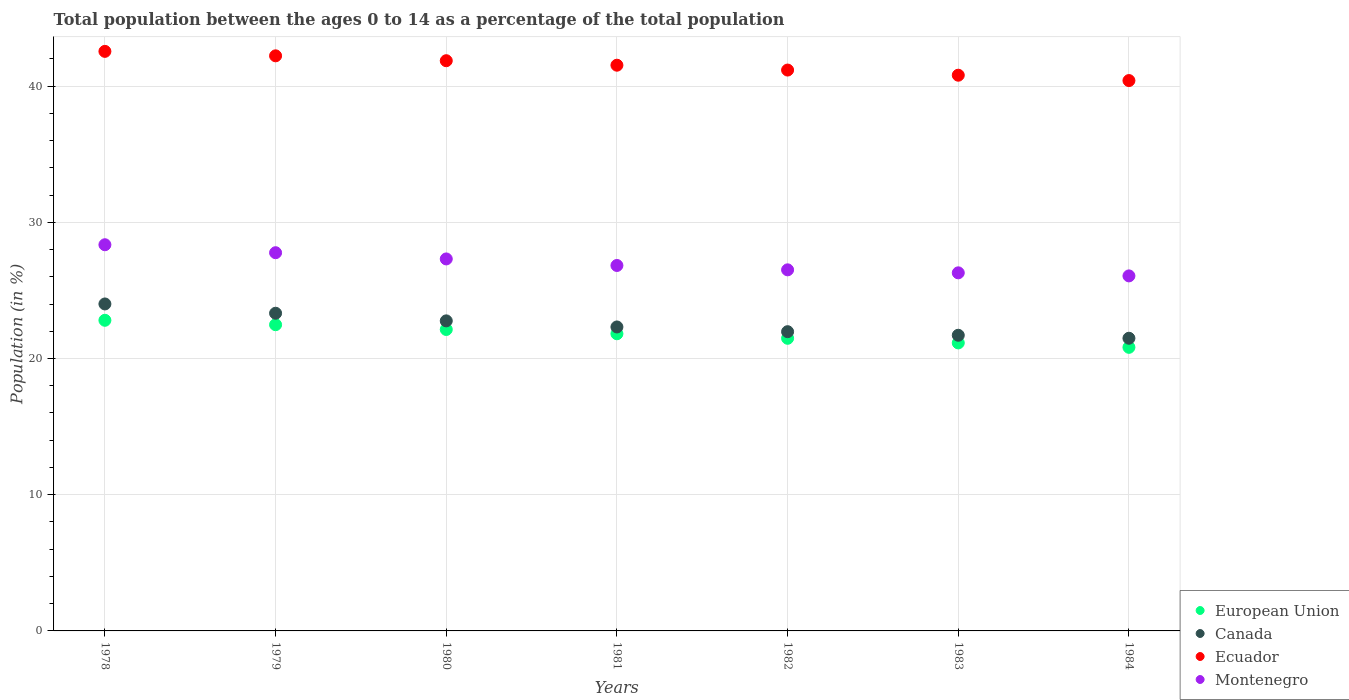Is the number of dotlines equal to the number of legend labels?
Offer a terse response. Yes. What is the percentage of the population ages 0 to 14 in Canada in 1981?
Give a very brief answer. 22.32. Across all years, what is the maximum percentage of the population ages 0 to 14 in Ecuador?
Give a very brief answer. 42.55. Across all years, what is the minimum percentage of the population ages 0 to 14 in Montenegro?
Your answer should be compact. 26.07. In which year was the percentage of the population ages 0 to 14 in Canada maximum?
Your answer should be very brief. 1978. What is the total percentage of the population ages 0 to 14 in European Union in the graph?
Ensure brevity in your answer.  152.69. What is the difference between the percentage of the population ages 0 to 14 in Ecuador in 1979 and that in 1982?
Your response must be concise. 1.04. What is the difference between the percentage of the population ages 0 to 14 in Canada in 1984 and the percentage of the population ages 0 to 14 in Montenegro in 1982?
Provide a short and direct response. -5.02. What is the average percentage of the population ages 0 to 14 in Montenegro per year?
Give a very brief answer. 27.02. In the year 1980, what is the difference between the percentage of the population ages 0 to 14 in Ecuador and percentage of the population ages 0 to 14 in European Union?
Make the answer very short. 19.73. In how many years, is the percentage of the population ages 0 to 14 in Ecuador greater than 28?
Offer a terse response. 7. What is the ratio of the percentage of the population ages 0 to 14 in Montenegro in 1979 to that in 1981?
Offer a terse response. 1.03. Is the percentage of the population ages 0 to 14 in European Union in 1980 less than that in 1982?
Offer a very short reply. No. Is the difference between the percentage of the population ages 0 to 14 in Ecuador in 1979 and 1982 greater than the difference between the percentage of the population ages 0 to 14 in European Union in 1979 and 1982?
Offer a very short reply. Yes. What is the difference between the highest and the second highest percentage of the population ages 0 to 14 in Canada?
Your response must be concise. 0.68. What is the difference between the highest and the lowest percentage of the population ages 0 to 14 in Ecuador?
Give a very brief answer. 2.14. Is the sum of the percentage of the population ages 0 to 14 in Montenegro in 1978 and 1980 greater than the maximum percentage of the population ages 0 to 14 in Canada across all years?
Offer a very short reply. Yes. Is it the case that in every year, the sum of the percentage of the population ages 0 to 14 in European Union and percentage of the population ages 0 to 14 in Montenegro  is greater than the percentage of the population ages 0 to 14 in Ecuador?
Provide a short and direct response. Yes. Does the percentage of the population ages 0 to 14 in Ecuador monotonically increase over the years?
Keep it short and to the point. No. How many dotlines are there?
Keep it short and to the point. 4. What is the difference between two consecutive major ticks on the Y-axis?
Give a very brief answer. 10. Are the values on the major ticks of Y-axis written in scientific E-notation?
Make the answer very short. No. Where does the legend appear in the graph?
Your response must be concise. Bottom right. How many legend labels are there?
Your answer should be compact. 4. What is the title of the graph?
Your response must be concise. Total population between the ages 0 to 14 as a percentage of the total population. Does "Morocco" appear as one of the legend labels in the graph?
Make the answer very short. No. What is the label or title of the X-axis?
Ensure brevity in your answer.  Years. What is the label or title of the Y-axis?
Give a very brief answer. Population (in %). What is the Population (in %) of European Union in 1978?
Offer a terse response. 22.81. What is the Population (in %) of Canada in 1978?
Give a very brief answer. 24.01. What is the Population (in %) in Ecuador in 1978?
Offer a very short reply. 42.55. What is the Population (in %) in Montenegro in 1978?
Keep it short and to the point. 28.35. What is the Population (in %) in European Union in 1979?
Keep it short and to the point. 22.48. What is the Population (in %) in Canada in 1979?
Give a very brief answer. 23.32. What is the Population (in %) of Ecuador in 1979?
Offer a terse response. 42.22. What is the Population (in %) of Montenegro in 1979?
Offer a terse response. 27.77. What is the Population (in %) in European Union in 1980?
Your response must be concise. 22.13. What is the Population (in %) of Canada in 1980?
Make the answer very short. 22.76. What is the Population (in %) of Ecuador in 1980?
Your response must be concise. 41.86. What is the Population (in %) in Montenegro in 1980?
Give a very brief answer. 27.31. What is the Population (in %) in European Union in 1981?
Keep it short and to the point. 21.82. What is the Population (in %) in Canada in 1981?
Your answer should be compact. 22.32. What is the Population (in %) in Ecuador in 1981?
Keep it short and to the point. 41.53. What is the Population (in %) of Montenegro in 1981?
Make the answer very short. 26.83. What is the Population (in %) of European Union in 1982?
Provide a succinct answer. 21.48. What is the Population (in %) of Canada in 1982?
Make the answer very short. 21.97. What is the Population (in %) of Ecuador in 1982?
Offer a terse response. 41.18. What is the Population (in %) of Montenegro in 1982?
Your response must be concise. 26.51. What is the Population (in %) of European Union in 1983?
Provide a succinct answer. 21.15. What is the Population (in %) of Canada in 1983?
Keep it short and to the point. 21.71. What is the Population (in %) in Ecuador in 1983?
Your answer should be very brief. 40.8. What is the Population (in %) in Montenegro in 1983?
Your response must be concise. 26.29. What is the Population (in %) in European Union in 1984?
Your answer should be compact. 20.82. What is the Population (in %) in Canada in 1984?
Make the answer very short. 21.49. What is the Population (in %) in Ecuador in 1984?
Keep it short and to the point. 40.41. What is the Population (in %) in Montenegro in 1984?
Your answer should be very brief. 26.07. Across all years, what is the maximum Population (in %) of European Union?
Make the answer very short. 22.81. Across all years, what is the maximum Population (in %) of Canada?
Give a very brief answer. 24.01. Across all years, what is the maximum Population (in %) of Ecuador?
Keep it short and to the point. 42.55. Across all years, what is the maximum Population (in %) of Montenegro?
Offer a very short reply. 28.35. Across all years, what is the minimum Population (in %) of European Union?
Your answer should be compact. 20.82. Across all years, what is the minimum Population (in %) in Canada?
Make the answer very short. 21.49. Across all years, what is the minimum Population (in %) in Ecuador?
Keep it short and to the point. 40.41. Across all years, what is the minimum Population (in %) of Montenegro?
Give a very brief answer. 26.07. What is the total Population (in %) in European Union in the graph?
Give a very brief answer. 152.69. What is the total Population (in %) in Canada in the graph?
Keep it short and to the point. 157.57. What is the total Population (in %) in Ecuador in the graph?
Offer a terse response. 290.56. What is the total Population (in %) in Montenegro in the graph?
Make the answer very short. 189.13. What is the difference between the Population (in %) of European Union in 1978 and that in 1979?
Make the answer very short. 0.33. What is the difference between the Population (in %) of Canada in 1978 and that in 1979?
Keep it short and to the point. 0.68. What is the difference between the Population (in %) of Ecuador in 1978 and that in 1979?
Give a very brief answer. 0.33. What is the difference between the Population (in %) in Montenegro in 1978 and that in 1979?
Provide a succinct answer. 0.59. What is the difference between the Population (in %) in European Union in 1978 and that in 1980?
Offer a terse response. 0.68. What is the difference between the Population (in %) in Canada in 1978 and that in 1980?
Give a very brief answer. 1.24. What is the difference between the Population (in %) of Ecuador in 1978 and that in 1980?
Your response must be concise. 0.69. What is the difference between the Population (in %) of Montenegro in 1978 and that in 1980?
Keep it short and to the point. 1.04. What is the difference between the Population (in %) of European Union in 1978 and that in 1981?
Your answer should be very brief. 0.99. What is the difference between the Population (in %) of Canada in 1978 and that in 1981?
Keep it short and to the point. 1.69. What is the difference between the Population (in %) in Ecuador in 1978 and that in 1981?
Keep it short and to the point. 1.02. What is the difference between the Population (in %) in Montenegro in 1978 and that in 1981?
Your answer should be compact. 1.52. What is the difference between the Population (in %) in European Union in 1978 and that in 1982?
Keep it short and to the point. 1.32. What is the difference between the Population (in %) in Canada in 1978 and that in 1982?
Keep it short and to the point. 2.04. What is the difference between the Population (in %) in Ecuador in 1978 and that in 1982?
Provide a short and direct response. 1.37. What is the difference between the Population (in %) of Montenegro in 1978 and that in 1982?
Your response must be concise. 1.84. What is the difference between the Population (in %) in European Union in 1978 and that in 1983?
Your response must be concise. 1.66. What is the difference between the Population (in %) of Canada in 1978 and that in 1983?
Give a very brief answer. 2.3. What is the difference between the Population (in %) of Ecuador in 1978 and that in 1983?
Give a very brief answer. 1.75. What is the difference between the Population (in %) in Montenegro in 1978 and that in 1983?
Your answer should be very brief. 2.06. What is the difference between the Population (in %) of European Union in 1978 and that in 1984?
Your answer should be compact. 1.99. What is the difference between the Population (in %) of Canada in 1978 and that in 1984?
Make the answer very short. 2.52. What is the difference between the Population (in %) in Ecuador in 1978 and that in 1984?
Your answer should be very brief. 2.14. What is the difference between the Population (in %) of Montenegro in 1978 and that in 1984?
Offer a very short reply. 2.29. What is the difference between the Population (in %) in European Union in 1979 and that in 1980?
Make the answer very short. 0.35. What is the difference between the Population (in %) of Canada in 1979 and that in 1980?
Your answer should be very brief. 0.56. What is the difference between the Population (in %) in Ecuador in 1979 and that in 1980?
Your answer should be very brief. 0.36. What is the difference between the Population (in %) in Montenegro in 1979 and that in 1980?
Your answer should be compact. 0.46. What is the difference between the Population (in %) in European Union in 1979 and that in 1981?
Offer a very short reply. 0.66. What is the difference between the Population (in %) in Ecuador in 1979 and that in 1981?
Provide a short and direct response. 0.69. What is the difference between the Population (in %) of Montenegro in 1979 and that in 1981?
Your answer should be compact. 0.94. What is the difference between the Population (in %) of Canada in 1979 and that in 1982?
Give a very brief answer. 1.35. What is the difference between the Population (in %) of Ecuador in 1979 and that in 1982?
Your answer should be compact. 1.04. What is the difference between the Population (in %) of Montenegro in 1979 and that in 1982?
Give a very brief answer. 1.26. What is the difference between the Population (in %) in European Union in 1979 and that in 1983?
Offer a very short reply. 1.34. What is the difference between the Population (in %) in Canada in 1979 and that in 1983?
Offer a terse response. 1.62. What is the difference between the Population (in %) of Ecuador in 1979 and that in 1983?
Make the answer very short. 1.42. What is the difference between the Population (in %) of Montenegro in 1979 and that in 1983?
Make the answer very short. 1.48. What is the difference between the Population (in %) of European Union in 1979 and that in 1984?
Provide a succinct answer. 1.66. What is the difference between the Population (in %) of Canada in 1979 and that in 1984?
Ensure brevity in your answer.  1.84. What is the difference between the Population (in %) in Ecuador in 1979 and that in 1984?
Offer a terse response. 1.82. What is the difference between the Population (in %) of Montenegro in 1979 and that in 1984?
Give a very brief answer. 1.7. What is the difference between the Population (in %) of European Union in 1980 and that in 1981?
Your answer should be compact. 0.31. What is the difference between the Population (in %) of Canada in 1980 and that in 1981?
Provide a short and direct response. 0.45. What is the difference between the Population (in %) in Ecuador in 1980 and that in 1981?
Offer a very short reply. 0.33. What is the difference between the Population (in %) in Montenegro in 1980 and that in 1981?
Provide a short and direct response. 0.48. What is the difference between the Population (in %) in European Union in 1980 and that in 1982?
Ensure brevity in your answer.  0.65. What is the difference between the Population (in %) of Canada in 1980 and that in 1982?
Offer a terse response. 0.79. What is the difference between the Population (in %) in Ecuador in 1980 and that in 1982?
Your answer should be compact. 0.69. What is the difference between the Population (in %) of Montenegro in 1980 and that in 1982?
Ensure brevity in your answer.  0.8. What is the difference between the Population (in %) in European Union in 1980 and that in 1983?
Offer a very short reply. 0.99. What is the difference between the Population (in %) of Canada in 1980 and that in 1983?
Your answer should be compact. 1.06. What is the difference between the Population (in %) in Ecuador in 1980 and that in 1983?
Offer a very short reply. 1.06. What is the difference between the Population (in %) of Montenegro in 1980 and that in 1983?
Provide a short and direct response. 1.02. What is the difference between the Population (in %) of European Union in 1980 and that in 1984?
Provide a short and direct response. 1.31. What is the difference between the Population (in %) in Canada in 1980 and that in 1984?
Keep it short and to the point. 1.28. What is the difference between the Population (in %) in Ecuador in 1980 and that in 1984?
Keep it short and to the point. 1.46. What is the difference between the Population (in %) of Montenegro in 1980 and that in 1984?
Your response must be concise. 1.25. What is the difference between the Population (in %) in European Union in 1981 and that in 1982?
Keep it short and to the point. 0.33. What is the difference between the Population (in %) in Canada in 1981 and that in 1982?
Make the answer very short. 0.35. What is the difference between the Population (in %) in Ecuador in 1981 and that in 1982?
Offer a very short reply. 0.36. What is the difference between the Population (in %) of Montenegro in 1981 and that in 1982?
Provide a succinct answer. 0.32. What is the difference between the Population (in %) in European Union in 1981 and that in 1983?
Give a very brief answer. 0.67. What is the difference between the Population (in %) in Canada in 1981 and that in 1983?
Your response must be concise. 0.61. What is the difference between the Population (in %) in Ecuador in 1981 and that in 1983?
Give a very brief answer. 0.73. What is the difference between the Population (in %) of Montenegro in 1981 and that in 1983?
Offer a very short reply. 0.54. What is the difference between the Population (in %) in Canada in 1981 and that in 1984?
Offer a very short reply. 0.83. What is the difference between the Population (in %) of Ecuador in 1981 and that in 1984?
Offer a very short reply. 1.13. What is the difference between the Population (in %) in Montenegro in 1981 and that in 1984?
Make the answer very short. 0.76. What is the difference between the Population (in %) of European Union in 1982 and that in 1983?
Offer a terse response. 0.34. What is the difference between the Population (in %) in Canada in 1982 and that in 1983?
Provide a short and direct response. 0.26. What is the difference between the Population (in %) of Ecuador in 1982 and that in 1983?
Give a very brief answer. 0.38. What is the difference between the Population (in %) of Montenegro in 1982 and that in 1983?
Provide a short and direct response. 0.22. What is the difference between the Population (in %) in European Union in 1982 and that in 1984?
Ensure brevity in your answer.  0.66. What is the difference between the Population (in %) of Canada in 1982 and that in 1984?
Provide a short and direct response. 0.48. What is the difference between the Population (in %) of Ecuador in 1982 and that in 1984?
Provide a succinct answer. 0.77. What is the difference between the Population (in %) in Montenegro in 1982 and that in 1984?
Provide a succinct answer. 0.44. What is the difference between the Population (in %) of European Union in 1983 and that in 1984?
Ensure brevity in your answer.  0.32. What is the difference between the Population (in %) of Canada in 1983 and that in 1984?
Give a very brief answer. 0.22. What is the difference between the Population (in %) in Ecuador in 1983 and that in 1984?
Keep it short and to the point. 0.39. What is the difference between the Population (in %) in Montenegro in 1983 and that in 1984?
Your answer should be very brief. 0.22. What is the difference between the Population (in %) in European Union in 1978 and the Population (in %) in Canada in 1979?
Make the answer very short. -0.52. What is the difference between the Population (in %) of European Union in 1978 and the Population (in %) of Ecuador in 1979?
Ensure brevity in your answer.  -19.42. What is the difference between the Population (in %) of European Union in 1978 and the Population (in %) of Montenegro in 1979?
Give a very brief answer. -4.96. What is the difference between the Population (in %) in Canada in 1978 and the Population (in %) in Ecuador in 1979?
Keep it short and to the point. -18.22. What is the difference between the Population (in %) in Canada in 1978 and the Population (in %) in Montenegro in 1979?
Give a very brief answer. -3.76. What is the difference between the Population (in %) of Ecuador in 1978 and the Population (in %) of Montenegro in 1979?
Keep it short and to the point. 14.78. What is the difference between the Population (in %) in European Union in 1978 and the Population (in %) in Canada in 1980?
Offer a very short reply. 0.04. What is the difference between the Population (in %) in European Union in 1978 and the Population (in %) in Ecuador in 1980?
Make the answer very short. -19.06. What is the difference between the Population (in %) of European Union in 1978 and the Population (in %) of Montenegro in 1980?
Ensure brevity in your answer.  -4.5. What is the difference between the Population (in %) in Canada in 1978 and the Population (in %) in Ecuador in 1980?
Your answer should be very brief. -17.86. What is the difference between the Population (in %) in Canada in 1978 and the Population (in %) in Montenegro in 1980?
Provide a short and direct response. -3.31. What is the difference between the Population (in %) of Ecuador in 1978 and the Population (in %) of Montenegro in 1980?
Offer a very short reply. 15.24. What is the difference between the Population (in %) in European Union in 1978 and the Population (in %) in Canada in 1981?
Keep it short and to the point. 0.49. What is the difference between the Population (in %) in European Union in 1978 and the Population (in %) in Ecuador in 1981?
Give a very brief answer. -18.73. What is the difference between the Population (in %) of European Union in 1978 and the Population (in %) of Montenegro in 1981?
Your answer should be compact. -4.02. What is the difference between the Population (in %) in Canada in 1978 and the Population (in %) in Ecuador in 1981?
Provide a succinct answer. -17.53. What is the difference between the Population (in %) in Canada in 1978 and the Population (in %) in Montenegro in 1981?
Your answer should be compact. -2.82. What is the difference between the Population (in %) of Ecuador in 1978 and the Population (in %) of Montenegro in 1981?
Offer a terse response. 15.72. What is the difference between the Population (in %) of European Union in 1978 and the Population (in %) of Canada in 1982?
Offer a very short reply. 0.84. What is the difference between the Population (in %) of European Union in 1978 and the Population (in %) of Ecuador in 1982?
Your response must be concise. -18.37. What is the difference between the Population (in %) of European Union in 1978 and the Population (in %) of Montenegro in 1982?
Offer a very short reply. -3.7. What is the difference between the Population (in %) in Canada in 1978 and the Population (in %) in Ecuador in 1982?
Your answer should be compact. -17.17. What is the difference between the Population (in %) in Canada in 1978 and the Population (in %) in Montenegro in 1982?
Provide a short and direct response. -2.5. What is the difference between the Population (in %) in Ecuador in 1978 and the Population (in %) in Montenegro in 1982?
Your answer should be compact. 16.04. What is the difference between the Population (in %) of European Union in 1978 and the Population (in %) of Canada in 1983?
Your response must be concise. 1.1. What is the difference between the Population (in %) of European Union in 1978 and the Population (in %) of Ecuador in 1983?
Offer a very short reply. -17.99. What is the difference between the Population (in %) in European Union in 1978 and the Population (in %) in Montenegro in 1983?
Ensure brevity in your answer.  -3.48. What is the difference between the Population (in %) of Canada in 1978 and the Population (in %) of Ecuador in 1983?
Ensure brevity in your answer.  -16.79. What is the difference between the Population (in %) of Canada in 1978 and the Population (in %) of Montenegro in 1983?
Your response must be concise. -2.29. What is the difference between the Population (in %) of Ecuador in 1978 and the Population (in %) of Montenegro in 1983?
Your answer should be very brief. 16.26. What is the difference between the Population (in %) of European Union in 1978 and the Population (in %) of Canada in 1984?
Make the answer very short. 1.32. What is the difference between the Population (in %) in European Union in 1978 and the Population (in %) in Ecuador in 1984?
Keep it short and to the point. -17.6. What is the difference between the Population (in %) in European Union in 1978 and the Population (in %) in Montenegro in 1984?
Your answer should be very brief. -3.26. What is the difference between the Population (in %) of Canada in 1978 and the Population (in %) of Ecuador in 1984?
Keep it short and to the point. -16.4. What is the difference between the Population (in %) of Canada in 1978 and the Population (in %) of Montenegro in 1984?
Ensure brevity in your answer.  -2.06. What is the difference between the Population (in %) in Ecuador in 1978 and the Population (in %) in Montenegro in 1984?
Your answer should be compact. 16.48. What is the difference between the Population (in %) of European Union in 1979 and the Population (in %) of Canada in 1980?
Offer a very short reply. -0.28. What is the difference between the Population (in %) in European Union in 1979 and the Population (in %) in Ecuador in 1980?
Make the answer very short. -19.38. What is the difference between the Population (in %) in European Union in 1979 and the Population (in %) in Montenegro in 1980?
Provide a short and direct response. -4.83. What is the difference between the Population (in %) in Canada in 1979 and the Population (in %) in Ecuador in 1980?
Keep it short and to the point. -18.54. What is the difference between the Population (in %) of Canada in 1979 and the Population (in %) of Montenegro in 1980?
Ensure brevity in your answer.  -3.99. What is the difference between the Population (in %) of Ecuador in 1979 and the Population (in %) of Montenegro in 1980?
Offer a very short reply. 14.91. What is the difference between the Population (in %) in European Union in 1979 and the Population (in %) in Canada in 1981?
Offer a very short reply. 0.16. What is the difference between the Population (in %) in European Union in 1979 and the Population (in %) in Ecuador in 1981?
Provide a succinct answer. -19.05. What is the difference between the Population (in %) in European Union in 1979 and the Population (in %) in Montenegro in 1981?
Your response must be concise. -4.35. What is the difference between the Population (in %) in Canada in 1979 and the Population (in %) in Ecuador in 1981?
Your answer should be compact. -18.21. What is the difference between the Population (in %) of Canada in 1979 and the Population (in %) of Montenegro in 1981?
Provide a short and direct response. -3.51. What is the difference between the Population (in %) of Ecuador in 1979 and the Population (in %) of Montenegro in 1981?
Make the answer very short. 15.39. What is the difference between the Population (in %) in European Union in 1979 and the Population (in %) in Canada in 1982?
Your response must be concise. 0.51. What is the difference between the Population (in %) in European Union in 1979 and the Population (in %) in Ecuador in 1982?
Provide a succinct answer. -18.7. What is the difference between the Population (in %) in European Union in 1979 and the Population (in %) in Montenegro in 1982?
Make the answer very short. -4.03. What is the difference between the Population (in %) in Canada in 1979 and the Population (in %) in Ecuador in 1982?
Provide a succinct answer. -17.85. What is the difference between the Population (in %) of Canada in 1979 and the Population (in %) of Montenegro in 1982?
Your response must be concise. -3.19. What is the difference between the Population (in %) of Ecuador in 1979 and the Population (in %) of Montenegro in 1982?
Offer a very short reply. 15.71. What is the difference between the Population (in %) in European Union in 1979 and the Population (in %) in Canada in 1983?
Offer a very short reply. 0.77. What is the difference between the Population (in %) of European Union in 1979 and the Population (in %) of Ecuador in 1983?
Your response must be concise. -18.32. What is the difference between the Population (in %) of European Union in 1979 and the Population (in %) of Montenegro in 1983?
Your answer should be very brief. -3.81. What is the difference between the Population (in %) in Canada in 1979 and the Population (in %) in Ecuador in 1983?
Your answer should be compact. -17.48. What is the difference between the Population (in %) in Canada in 1979 and the Population (in %) in Montenegro in 1983?
Your answer should be compact. -2.97. What is the difference between the Population (in %) of Ecuador in 1979 and the Population (in %) of Montenegro in 1983?
Offer a terse response. 15.93. What is the difference between the Population (in %) of European Union in 1979 and the Population (in %) of Ecuador in 1984?
Your response must be concise. -17.93. What is the difference between the Population (in %) in European Union in 1979 and the Population (in %) in Montenegro in 1984?
Your response must be concise. -3.58. What is the difference between the Population (in %) in Canada in 1979 and the Population (in %) in Ecuador in 1984?
Your answer should be very brief. -17.08. What is the difference between the Population (in %) of Canada in 1979 and the Population (in %) of Montenegro in 1984?
Offer a very short reply. -2.74. What is the difference between the Population (in %) in Ecuador in 1979 and the Population (in %) in Montenegro in 1984?
Offer a terse response. 16.16. What is the difference between the Population (in %) of European Union in 1980 and the Population (in %) of Canada in 1981?
Your response must be concise. -0.19. What is the difference between the Population (in %) in European Union in 1980 and the Population (in %) in Ecuador in 1981?
Your response must be concise. -19.4. What is the difference between the Population (in %) of European Union in 1980 and the Population (in %) of Montenegro in 1981?
Your response must be concise. -4.7. What is the difference between the Population (in %) in Canada in 1980 and the Population (in %) in Ecuador in 1981?
Your answer should be compact. -18.77. What is the difference between the Population (in %) of Canada in 1980 and the Population (in %) of Montenegro in 1981?
Make the answer very short. -4.07. What is the difference between the Population (in %) in Ecuador in 1980 and the Population (in %) in Montenegro in 1981?
Ensure brevity in your answer.  15.03. What is the difference between the Population (in %) of European Union in 1980 and the Population (in %) of Canada in 1982?
Make the answer very short. 0.16. What is the difference between the Population (in %) of European Union in 1980 and the Population (in %) of Ecuador in 1982?
Your response must be concise. -19.05. What is the difference between the Population (in %) of European Union in 1980 and the Population (in %) of Montenegro in 1982?
Your response must be concise. -4.38. What is the difference between the Population (in %) in Canada in 1980 and the Population (in %) in Ecuador in 1982?
Your answer should be very brief. -18.41. What is the difference between the Population (in %) of Canada in 1980 and the Population (in %) of Montenegro in 1982?
Provide a succinct answer. -3.75. What is the difference between the Population (in %) of Ecuador in 1980 and the Population (in %) of Montenegro in 1982?
Offer a terse response. 15.35. What is the difference between the Population (in %) in European Union in 1980 and the Population (in %) in Canada in 1983?
Provide a succinct answer. 0.42. What is the difference between the Population (in %) of European Union in 1980 and the Population (in %) of Ecuador in 1983?
Offer a terse response. -18.67. What is the difference between the Population (in %) of European Union in 1980 and the Population (in %) of Montenegro in 1983?
Keep it short and to the point. -4.16. What is the difference between the Population (in %) in Canada in 1980 and the Population (in %) in Ecuador in 1983?
Offer a very short reply. -18.04. What is the difference between the Population (in %) in Canada in 1980 and the Population (in %) in Montenegro in 1983?
Ensure brevity in your answer.  -3.53. What is the difference between the Population (in %) in Ecuador in 1980 and the Population (in %) in Montenegro in 1983?
Make the answer very short. 15.57. What is the difference between the Population (in %) of European Union in 1980 and the Population (in %) of Canada in 1984?
Your response must be concise. 0.64. What is the difference between the Population (in %) in European Union in 1980 and the Population (in %) in Ecuador in 1984?
Your response must be concise. -18.28. What is the difference between the Population (in %) in European Union in 1980 and the Population (in %) in Montenegro in 1984?
Ensure brevity in your answer.  -3.93. What is the difference between the Population (in %) of Canada in 1980 and the Population (in %) of Ecuador in 1984?
Make the answer very short. -17.64. What is the difference between the Population (in %) of Canada in 1980 and the Population (in %) of Montenegro in 1984?
Your response must be concise. -3.3. What is the difference between the Population (in %) in Ecuador in 1980 and the Population (in %) in Montenegro in 1984?
Give a very brief answer. 15.8. What is the difference between the Population (in %) in European Union in 1981 and the Population (in %) in Canada in 1982?
Make the answer very short. -0.15. What is the difference between the Population (in %) in European Union in 1981 and the Population (in %) in Ecuador in 1982?
Offer a very short reply. -19.36. What is the difference between the Population (in %) in European Union in 1981 and the Population (in %) in Montenegro in 1982?
Give a very brief answer. -4.69. What is the difference between the Population (in %) in Canada in 1981 and the Population (in %) in Ecuador in 1982?
Make the answer very short. -18.86. What is the difference between the Population (in %) in Canada in 1981 and the Population (in %) in Montenegro in 1982?
Give a very brief answer. -4.19. What is the difference between the Population (in %) in Ecuador in 1981 and the Population (in %) in Montenegro in 1982?
Offer a terse response. 15.02. What is the difference between the Population (in %) of European Union in 1981 and the Population (in %) of Canada in 1983?
Make the answer very short. 0.11. What is the difference between the Population (in %) of European Union in 1981 and the Population (in %) of Ecuador in 1983?
Provide a succinct answer. -18.98. What is the difference between the Population (in %) in European Union in 1981 and the Population (in %) in Montenegro in 1983?
Provide a short and direct response. -4.47. What is the difference between the Population (in %) of Canada in 1981 and the Population (in %) of Ecuador in 1983?
Your answer should be compact. -18.48. What is the difference between the Population (in %) in Canada in 1981 and the Population (in %) in Montenegro in 1983?
Ensure brevity in your answer.  -3.97. What is the difference between the Population (in %) of Ecuador in 1981 and the Population (in %) of Montenegro in 1983?
Ensure brevity in your answer.  15.24. What is the difference between the Population (in %) of European Union in 1981 and the Population (in %) of Canada in 1984?
Your answer should be compact. 0.33. What is the difference between the Population (in %) of European Union in 1981 and the Population (in %) of Ecuador in 1984?
Your answer should be compact. -18.59. What is the difference between the Population (in %) in European Union in 1981 and the Population (in %) in Montenegro in 1984?
Give a very brief answer. -4.25. What is the difference between the Population (in %) of Canada in 1981 and the Population (in %) of Ecuador in 1984?
Offer a terse response. -18.09. What is the difference between the Population (in %) of Canada in 1981 and the Population (in %) of Montenegro in 1984?
Your answer should be compact. -3.75. What is the difference between the Population (in %) of Ecuador in 1981 and the Population (in %) of Montenegro in 1984?
Offer a very short reply. 15.47. What is the difference between the Population (in %) of European Union in 1982 and the Population (in %) of Canada in 1983?
Your response must be concise. -0.22. What is the difference between the Population (in %) in European Union in 1982 and the Population (in %) in Ecuador in 1983?
Offer a terse response. -19.32. What is the difference between the Population (in %) in European Union in 1982 and the Population (in %) in Montenegro in 1983?
Provide a short and direct response. -4.81. What is the difference between the Population (in %) of Canada in 1982 and the Population (in %) of Ecuador in 1983?
Give a very brief answer. -18.83. What is the difference between the Population (in %) of Canada in 1982 and the Population (in %) of Montenegro in 1983?
Provide a succinct answer. -4.32. What is the difference between the Population (in %) in Ecuador in 1982 and the Population (in %) in Montenegro in 1983?
Provide a succinct answer. 14.89. What is the difference between the Population (in %) of European Union in 1982 and the Population (in %) of Canada in 1984?
Keep it short and to the point. -0. What is the difference between the Population (in %) of European Union in 1982 and the Population (in %) of Ecuador in 1984?
Keep it short and to the point. -18.92. What is the difference between the Population (in %) of European Union in 1982 and the Population (in %) of Montenegro in 1984?
Your response must be concise. -4.58. What is the difference between the Population (in %) of Canada in 1982 and the Population (in %) of Ecuador in 1984?
Ensure brevity in your answer.  -18.44. What is the difference between the Population (in %) in Canada in 1982 and the Population (in %) in Montenegro in 1984?
Ensure brevity in your answer.  -4.1. What is the difference between the Population (in %) in Ecuador in 1982 and the Population (in %) in Montenegro in 1984?
Keep it short and to the point. 15.11. What is the difference between the Population (in %) in European Union in 1983 and the Population (in %) in Canada in 1984?
Your answer should be compact. -0.34. What is the difference between the Population (in %) in European Union in 1983 and the Population (in %) in Ecuador in 1984?
Make the answer very short. -19.26. What is the difference between the Population (in %) in European Union in 1983 and the Population (in %) in Montenegro in 1984?
Keep it short and to the point. -4.92. What is the difference between the Population (in %) of Canada in 1983 and the Population (in %) of Ecuador in 1984?
Offer a terse response. -18.7. What is the difference between the Population (in %) of Canada in 1983 and the Population (in %) of Montenegro in 1984?
Provide a short and direct response. -4.36. What is the difference between the Population (in %) in Ecuador in 1983 and the Population (in %) in Montenegro in 1984?
Provide a short and direct response. 14.73. What is the average Population (in %) of European Union per year?
Your answer should be very brief. 21.81. What is the average Population (in %) of Canada per year?
Offer a very short reply. 22.51. What is the average Population (in %) of Ecuador per year?
Give a very brief answer. 41.51. What is the average Population (in %) in Montenegro per year?
Ensure brevity in your answer.  27.02. In the year 1978, what is the difference between the Population (in %) in European Union and Population (in %) in Canada?
Ensure brevity in your answer.  -1.2. In the year 1978, what is the difference between the Population (in %) in European Union and Population (in %) in Ecuador?
Provide a short and direct response. -19.74. In the year 1978, what is the difference between the Population (in %) of European Union and Population (in %) of Montenegro?
Give a very brief answer. -5.55. In the year 1978, what is the difference between the Population (in %) of Canada and Population (in %) of Ecuador?
Give a very brief answer. -18.54. In the year 1978, what is the difference between the Population (in %) in Canada and Population (in %) in Montenegro?
Ensure brevity in your answer.  -4.35. In the year 1978, what is the difference between the Population (in %) of Ecuador and Population (in %) of Montenegro?
Ensure brevity in your answer.  14.2. In the year 1979, what is the difference between the Population (in %) in European Union and Population (in %) in Canada?
Your answer should be compact. -0.84. In the year 1979, what is the difference between the Population (in %) of European Union and Population (in %) of Ecuador?
Your response must be concise. -19.74. In the year 1979, what is the difference between the Population (in %) in European Union and Population (in %) in Montenegro?
Keep it short and to the point. -5.29. In the year 1979, what is the difference between the Population (in %) of Canada and Population (in %) of Ecuador?
Offer a terse response. -18.9. In the year 1979, what is the difference between the Population (in %) of Canada and Population (in %) of Montenegro?
Give a very brief answer. -4.44. In the year 1979, what is the difference between the Population (in %) in Ecuador and Population (in %) in Montenegro?
Give a very brief answer. 14.46. In the year 1980, what is the difference between the Population (in %) in European Union and Population (in %) in Canada?
Ensure brevity in your answer.  -0.63. In the year 1980, what is the difference between the Population (in %) of European Union and Population (in %) of Ecuador?
Provide a succinct answer. -19.73. In the year 1980, what is the difference between the Population (in %) of European Union and Population (in %) of Montenegro?
Your response must be concise. -5.18. In the year 1980, what is the difference between the Population (in %) in Canada and Population (in %) in Ecuador?
Make the answer very short. -19.1. In the year 1980, what is the difference between the Population (in %) of Canada and Population (in %) of Montenegro?
Ensure brevity in your answer.  -4.55. In the year 1980, what is the difference between the Population (in %) in Ecuador and Population (in %) in Montenegro?
Keep it short and to the point. 14.55. In the year 1981, what is the difference between the Population (in %) of European Union and Population (in %) of Canada?
Your answer should be very brief. -0.5. In the year 1981, what is the difference between the Population (in %) in European Union and Population (in %) in Ecuador?
Ensure brevity in your answer.  -19.72. In the year 1981, what is the difference between the Population (in %) of European Union and Population (in %) of Montenegro?
Offer a very short reply. -5.01. In the year 1981, what is the difference between the Population (in %) in Canada and Population (in %) in Ecuador?
Offer a terse response. -19.22. In the year 1981, what is the difference between the Population (in %) in Canada and Population (in %) in Montenegro?
Your answer should be compact. -4.51. In the year 1981, what is the difference between the Population (in %) of Ecuador and Population (in %) of Montenegro?
Make the answer very short. 14.7. In the year 1982, what is the difference between the Population (in %) of European Union and Population (in %) of Canada?
Ensure brevity in your answer.  -0.48. In the year 1982, what is the difference between the Population (in %) in European Union and Population (in %) in Ecuador?
Your answer should be very brief. -19.69. In the year 1982, what is the difference between the Population (in %) in European Union and Population (in %) in Montenegro?
Provide a short and direct response. -5.03. In the year 1982, what is the difference between the Population (in %) in Canada and Population (in %) in Ecuador?
Make the answer very short. -19.21. In the year 1982, what is the difference between the Population (in %) of Canada and Population (in %) of Montenegro?
Give a very brief answer. -4.54. In the year 1982, what is the difference between the Population (in %) in Ecuador and Population (in %) in Montenegro?
Provide a succinct answer. 14.67. In the year 1983, what is the difference between the Population (in %) in European Union and Population (in %) in Canada?
Keep it short and to the point. -0.56. In the year 1983, what is the difference between the Population (in %) of European Union and Population (in %) of Ecuador?
Provide a short and direct response. -19.65. In the year 1983, what is the difference between the Population (in %) in European Union and Population (in %) in Montenegro?
Give a very brief answer. -5.15. In the year 1983, what is the difference between the Population (in %) in Canada and Population (in %) in Ecuador?
Your answer should be very brief. -19.09. In the year 1983, what is the difference between the Population (in %) of Canada and Population (in %) of Montenegro?
Offer a terse response. -4.58. In the year 1983, what is the difference between the Population (in %) in Ecuador and Population (in %) in Montenegro?
Your answer should be compact. 14.51. In the year 1984, what is the difference between the Population (in %) in European Union and Population (in %) in Canada?
Your answer should be compact. -0.67. In the year 1984, what is the difference between the Population (in %) of European Union and Population (in %) of Ecuador?
Keep it short and to the point. -19.59. In the year 1984, what is the difference between the Population (in %) of European Union and Population (in %) of Montenegro?
Offer a very short reply. -5.25. In the year 1984, what is the difference between the Population (in %) in Canada and Population (in %) in Ecuador?
Offer a terse response. -18.92. In the year 1984, what is the difference between the Population (in %) in Canada and Population (in %) in Montenegro?
Offer a terse response. -4.58. In the year 1984, what is the difference between the Population (in %) of Ecuador and Population (in %) of Montenegro?
Provide a short and direct response. 14.34. What is the ratio of the Population (in %) of European Union in 1978 to that in 1979?
Ensure brevity in your answer.  1.01. What is the ratio of the Population (in %) of Canada in 1978 to that in 1979?
Provide a short and direct response. 1.03. What is the ratio of the Population (in %) of Ecuador in 1978 to that in 1979?
Your response must be concise. 1.01. What is the ratio of the Population (in %) in Montenegro in 1978 to that in 1979?
Your answer should be compact. 1.02. What is the ratio of the Population (in %) in European Union in 1978 to that in 1980?
Provide a short and direct response. 1.03. What is the ratio of the Population (in %) in Canada in 1978 to that in 1980?
Make the answer very short. 1.05. What is the ratio of the Population (in %) in Ecuador in 1978 to that in 1980?
Offer a very short reply. 1.02. What is the ratio of the Population (in %) in Montenegro in 1978 to that in 1980?
Your answer should be very brief. 1.04. What is the ratio of the Population (in %) of European Union in 1978 to that in 1981?
Your response must be concise. 1.05. What is the ratio of the Population (in %) in Canada in 1978 to that in 1981?
Offer a very short reply. 1.08. What is the ratio of the Population (in %) in Ecuador in 1978 to that in 1981?
Provide a short and direct response. 1.02. What is the ratio of the Population (in %) in Montenegro in 1978 to that in 1981?
Provide a succinct answer. 1.06. What is the ratio of the Population (in %) in European Union in 1978 to that in 1982?
Ensure brevity in your answer.  1.06. What is the ratio of the Population (in %) in Canada in 1978 to that in 1982?
Your answer should be very brief. 1.09. What is the ratio of the Population (in %) in Ecuador in 1978 to that in 1982?
Keep it short and to the point. 1.03. What is the ratio of the Population (in %) of Montenegro in 1978 to that in 1982?
Make the answer very short. 1.07. What is the ratio of the Population (in %) in European Union in 1978 to that in 1983?
Keep it short and to the point. 1.08. What is the ratio of the Population (in %) of Canada in 1978 to that in 1983?
Offer a very short reply. 1.11. What is the ratio of the Population (in %) of Ecuador in 1978 to that in 1983?
Your answer should be compact. 1.04. What is the ratio of the Population (in %) in Montenegro in 1978 to that in 1983?
Ensure brevity in your answer.  1.08. What is the ratio of the Population (in %) in European Union in 1978 to that in 1984?
Provide a succinct answer. 1.1. What is the ratio of the Population (in %) in Canada in 1978 to that in 1984?
Provide a succinct answer. 1.12. What is the ratio of the Population (in %) in Ecuador in 1978 to that in 1984?
Ensure brevity in your answer.  1.05. What is the ratio of the Population (in %) of Montenegro in 1978 to that in 1984?
Keep it short and to the point. 1.09. What is the ratio of the Population (in %) in European Union in 1979 to that in 1980?
Give a very brief answer. 1.02. What is the ratio of the Population (in %) of Canada in 1979 to that in 1980?
Offer a terse response. 1.02. What is the ratio of the Population (in %) in Ecuador in 1979 to that in 1980?
Ensure brevity in your answer.  1.01. What is the ratio of the Population (in %) in Montenegro in 1979 to that in 1980?
Provide a short and direct response. 1.02. What is the ratio of the Population (in %) in European Union in 1979 to that in 1981?
Offer a very short reply. 1.03. What is the ratio of the Population (in %) of Canada in 1979 to that in 1981?
Give a very brief answer. 1.05. What is the ratio of the Population (in %) in Ecuador in 1979 to that in 1981?
Offer a terse response. 1.02. What is the ratio of the Population (in %) of Montenegro in 1979 to that in 1981?
Your answer should be compact. 1.03. What is the ratio of the Population (in %) in European Union in 1979 to that in 1982?
Your response must be concise. 1.05. What is the ratio of the Population (in %) in Canada in 1979 to that in 1982?
Ensure brevity in your answer.  1.06. What is the ratio of the Population (in %) in Ecuador in 1979 to that in 1982?
Your answer should be very brief. 1.03. What is the ratio of the Population (in %) in Montenegro in 1979 to that in 1982?
Ensure brevity in your answer.  1.05. What is the ratio of the Population (in %) of European Union in 1979 to that in 1983?
Keep it short and to the point. 1.06. What is the ratio of the Population (in %) of Canada in 1979 to that in 1983?
Your answer should be very brief. 1.07. What is the ratio of the Population (in %) of Ecuador in 1979 to that in 1983?
Keep it short and to the point. 1.03. What is the ratio of the Population (in %) of Montenegro in 1979 to that in 1983?
Offer a terse response. 1.06. What is the ratio of the Population (in %) of European Union in 1979 to that in 1984?
Your answer should be compact. 1.08. What is the ratio of the Population (in %) of Canada in 1979 to that in 1984?
Provide a short and direct response. 1.09. What is the ratio of the Population (in %) of Ecuador in 1979 to that in 1984?
Provide a succinct answer. 1.04. What is the ratio of the Population (in %) of Montenegro in 1979 to that in 1984?
Your answer should be compact. 1.07. What is the ratio of the Population (in %) in European Union in 1980 to that in 1981?
Your answer should be compact. 1.01. What is the ratio of the Population (in %) of Canada in 1980 to that in 1981?
Make the answer very short. 1.02. What is the ratio of the Population (in %) in Ecuador in 1980 to that in 1981?
Ensure brevity in your answer.  1.01. What is the ratio of the Population (in %) in Montenegro in 1980 to that in 1981?
Provide a short and direct response. 1.02. What is the ratio of the Population (in %) of European Union in 1980 to that in 1982?
Ensure brevity in your answer.  1.03. What is the ratio of the Population (in %) in Canada in 1980 to that in 1982?
Make the answer very short. 1.04. What is the ratio of the Population (in %) of Ecuador in 1980 to that in 1982?
Give a very brief answer. 1.02. What is the ratio of the Population (in %) of Montenegro in 1980 to that in 1982?
Give a very brief answer. 1.03. What is the ratio of the Population (in %) in European Union in 1980 to that in 1983?
Provide a short and direct response. 1.05. What is the ratio of the Population (in %) in Canada in 1980 to that in 1983?
Provide a succinct answer. 1.05. What is the ratio of the Population (in %) in Ecuador in 1980 to that in 1983?
Make the answer very short. 1.03. What is the ratio of the Population (in %) in Montenegro in 1980 to that in 1983?
Offer a very short reply. 1.04. What is the ratio of the Population (in %) in European Union in 1980 to that in 1984?
Your response must be concise. 1.06. What is the ratio of the Population (in %) of Canada in 1980 to that in 1984?
Make the answer very short. 1.06. What is the ratio of the Population (in %) of Ecuador in 1980 to that in 1984?
Offer a terse response. 1.04. What is the ratio of the Population (in %) of Montenegro in 1980 to that in 1984?
Provide a short and direct response. 1.05. What is the ratio of the Population (in %) of European Union in 1981 to that in 1982?
Ensure brevity in your answer.  1.02. What is the ratio of the Population (in %) in Canada in 1981 to that in 1982?
Provide a short and direct response. 1.02. What is the ratio of the Population (in %) in Ecuador in 1981 to that in 1982?
Your answer should be very brief. 1.01. What is the ratio of the Population (in %) of Montenegro in 1981 to that in 1982?
Provide a succinct answer. 1.01. What is the ratio of the Population (in %) of European Union in 1981 to that in 1983?
Provide a short and direct response. 1.03. What is the ratio of the Population (in %) in Canada in 1981 to that in 1983?
Provide a short and direct response. 1.03. What is the ratio of the Population (in %) of Ecuador in 1981 to that in 1983?
Ensure brevity in your answer.  1.02. What is the ratio of the Population (in %) of Montenegro in 1981 to that in 1983?
Your answer should be compact. 1.02. What is the ratio of the Population (in %) of European Union in 1981 to that in 1984?
Make the answer very short. 1.05. What is the ratio of the Population (in %) of Canada in 1981 to that in 1984?
Provide a short and direct response. 1.04. What is the ratio of the Population (in %) of Ecuador in 1981 to that in 1984?
Offer a terse response. 1.03. What is the ratio of the Population (in %) of Montenegro in 1981 to that in 1984?
Give a very brief answer. 1.03. What is the ratio of the Population (in %) in European Union in 1982 to that in 1983?
Provide a succinct answer. 1.02. What is the ratio of the Population (in %) in Canada in 1982 to that in 1983?
Give a very brief answer. 1.01. What is the ratio of the Population (in %) of Ecuador in 1982 to that in 1983?
Your answer should be very brief. 1.01. What is the ratio of the Population (in %) in Montenegro in 1982 to that in 1983?
Offer a very short reply. 1.01. What is the ratio of the Population (in %) in European Union in 1982 to that in 1984?
Provide a succinct answer. 1.03. What is the ratio of the Population (in %) in Canada in 1982 to that in 1984?
Keep it short and to the point. 1.02. What is the ratio of the Population (in %) in Ecuador in 1982 to that in 1984?
Provide a succinct answer. 1.02. What is the ratio of the Population (in %) of Montenegro in 1982 to that in 1984?
Offer a terse response. 1.02. What is the ratio of the Population (in %) of European Union in 1983 to that in 1984?
Ensure brevity in your answer.  1.02. What is the ratio of the Population (in %) of Canada in 1983 to that in 1984?
Offer a very short reply. 1.01. What is the ratio of the Population (in %) in Ecuador in 1983 to that in 1984?
Offer a terse response. 1.01. What is the ratio of the Population (in %) of Montenegro in 1983 to that in 1984?
Ensure brevity in your answer.  1.01. What is the difference between the highest and the second highest Population (in %) in European Union?
Your answer should be very brief. 0.33. What is the difference between the highest and the second highest Population (in %) of Canada?
Provide a short and direct response. 0.68. What is the difference between the highest and the second highest Population (in %) in Ecuador?
Your response must be concise. 0.33. What is the difference between the highest and the second highest Population (in %) of Montenegro?
Your response must be concise. 0.59. What is the difference between the highest and the lowest Population (in %) of European Union?
Provide a succinct answer. 1.99. What is the difference between the highest and the lowest Population (in %) of Canada?
Offer a very short reply. 2.52. What is the difference between the highest and the lowest Population (in %) of Ecuador?
Make the answer very short. 2.14. What is the difference between the highest and the lowest Population (in %) in Montenegro?
Provide a succinct answer. 2.29. 